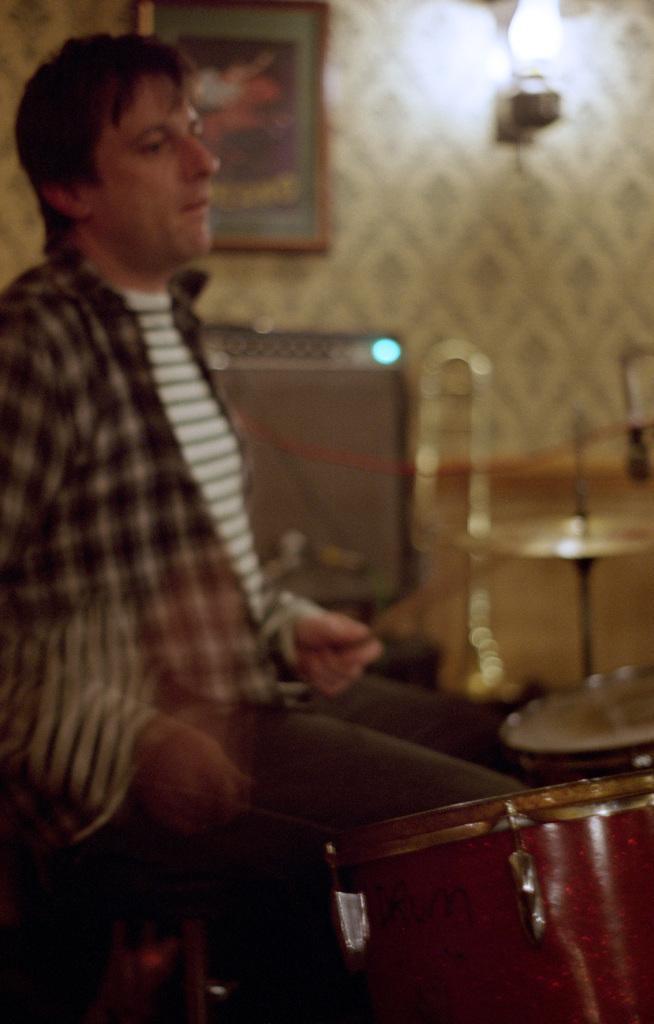Describe this image in one or two sentences. In this image there is one person who is sitting on a chair and he is holding sticks, in front of him there are some drum and it seems that he is playing drums. In the background there are some musical instruments and wall, on the top of the image there is one photo frame and light on the wall. 